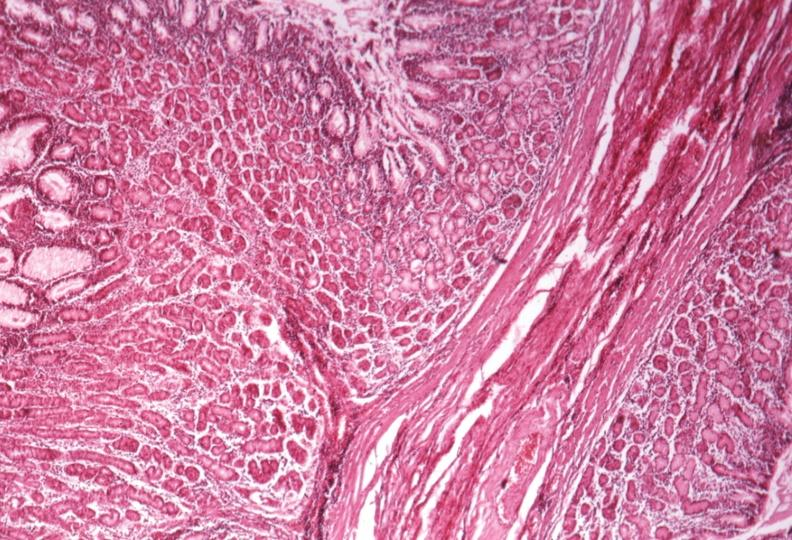what is present?
Answer the question using a single word or phrase. Stomach 